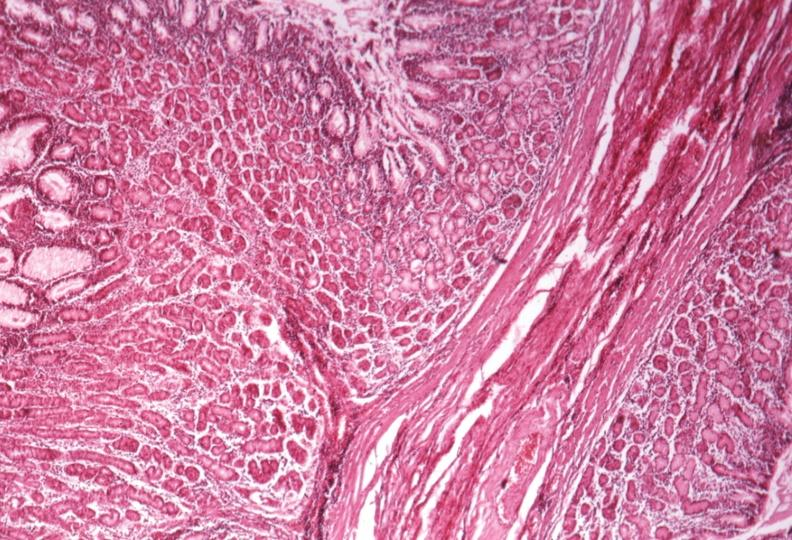what is present?
Answer the question using a single word or phrase. Stomach 